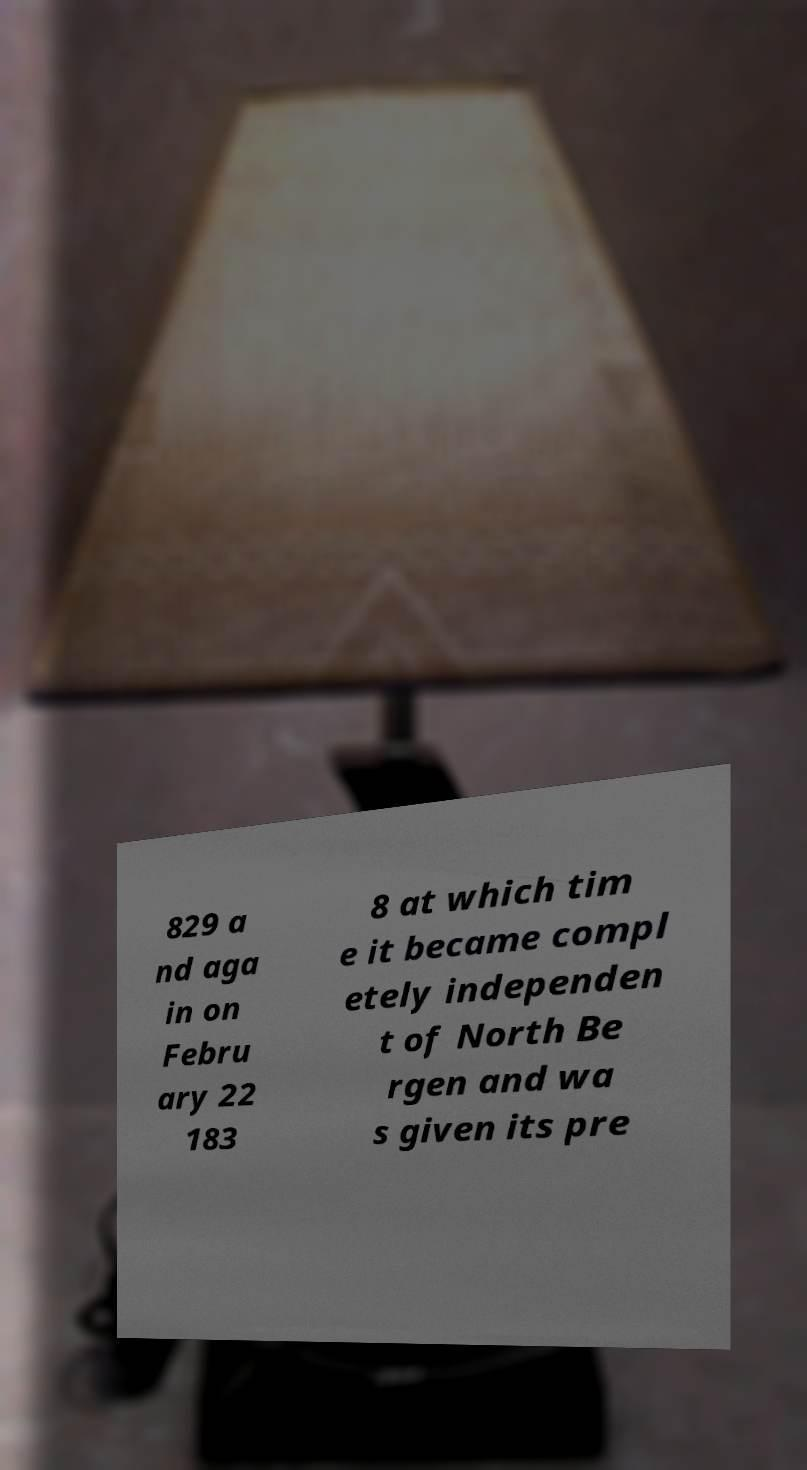For documentation purposes, I need the text within this image transcribed. Could you provide that? 829 a nd aga in on Febru ary 22 183 8 at which tim e it became compl etely independen t of North Be rgen and wa s given its pre 